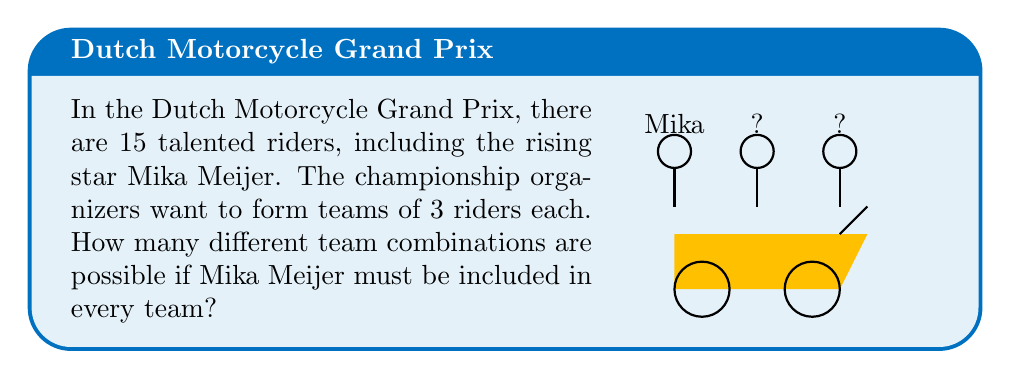Could you help me with this problem? Let's approach this step-by-step:

1) We know that Mika Meijer must be included in every team. This means we only need to select 2 more riders to complete each team.

2) Out of the total 15 riders, we've already selected Mika, so we have 14 riders left to choose from.

3) We need to select 2 riders from these 14. This is a combination problem, as the order of selection doesn't matter (selecting rider A then B is the same team as selecting B then A).

4) The formula for combinations is:

   $$C(n,r) = \frac{n!}{r!(n-r)!}$$

   where $n$ is the total number of items to choose from, and $r$ is the number of items being chosen.

5) In this case, $n = 14$ (the number of riders excluding Mika) and $r = 2$ (the number of additional riders we need to select).

6) Plugging these values into our formula:

   $$C(14,2) = \frac{14!}{2!(14-2)!} = \frac{14!}{2!12!}$$

7) Calculating this:
   
   $$\frac{14 \times 13 \times 12!}{2 \times 1 \times 12!} = \frac{14 \times 13}{2} = 91$$

Therefore, there are 91 possible team combinations.
Answer: 91 